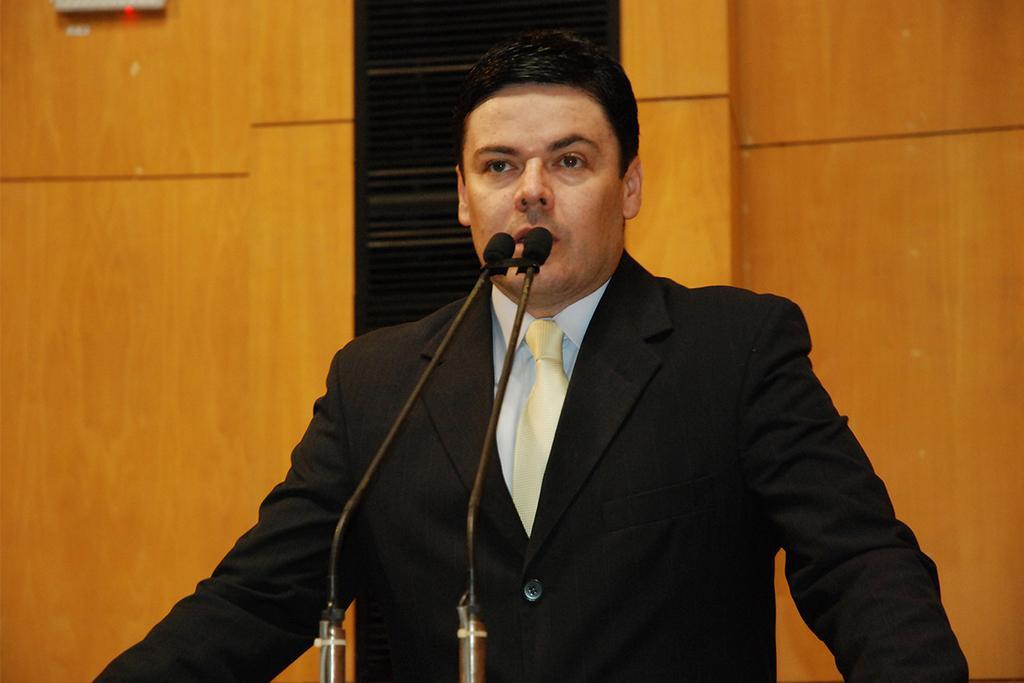How would you summarize this image in a sentence or two? In this image in the center there is one person who is talking in front of him there are mikes, and in the background there is a wooden wall and some objects. 